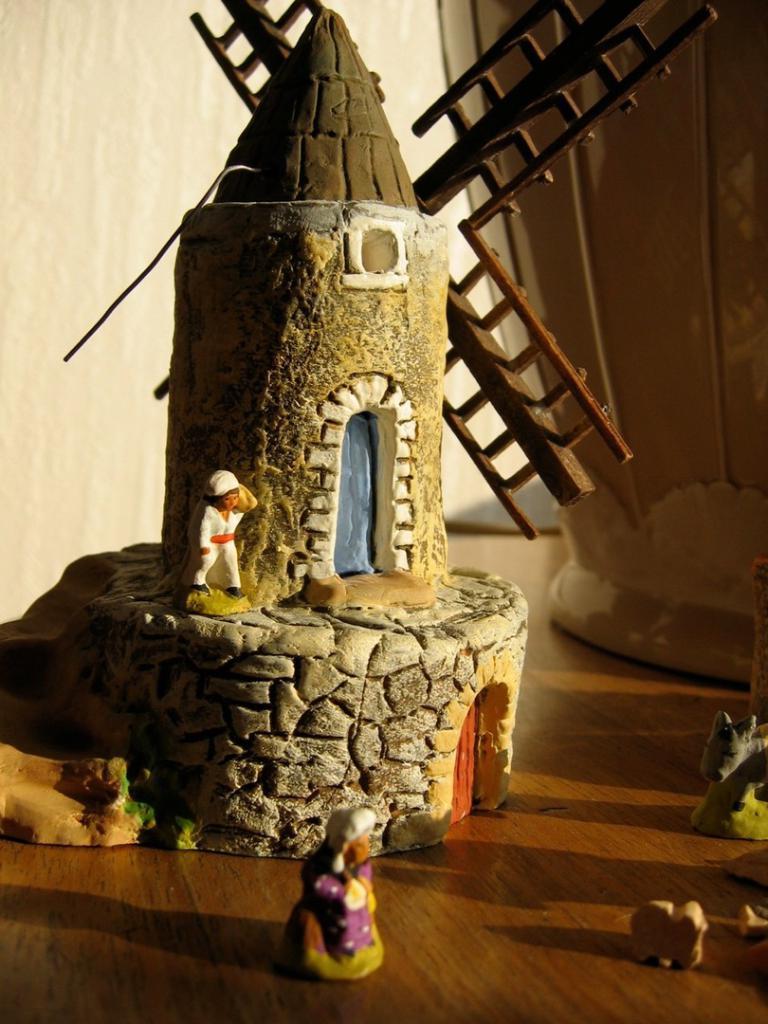Describe this image in one or two sentences. In this image, we can see a toy house with doors. Here we can see toy people and toy animals are placed on the wooden surface. Background there is a wall and pot. 